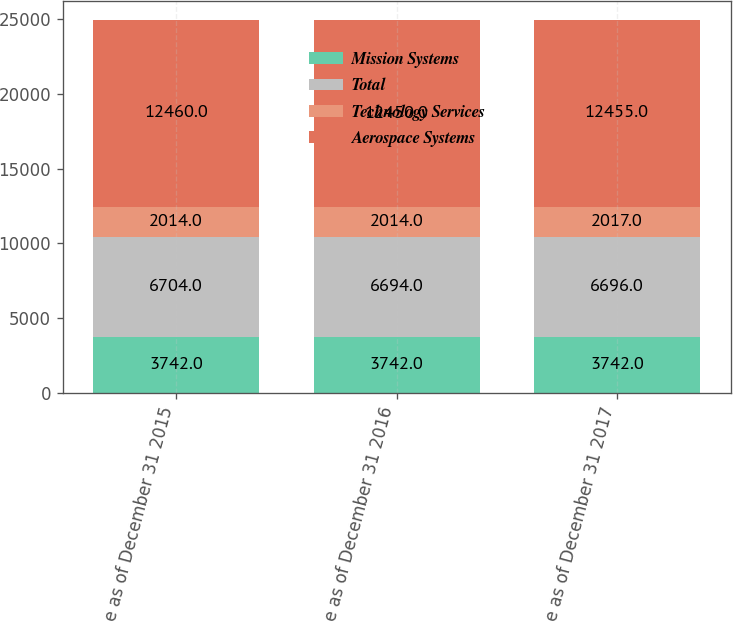Convert chart. <chart><loc_0><loc_0><loc_500><loc_500><stacked_bar_chart><ecel><fcel>Balance as of December 31 2015<fcel>Balance as of December 31 2016<fcel>Balance as of December 31 2017<nl><fcel>Mission Systems<fcel>3742<fcel>3742<fcel>3742<nl><fcel>Total<fcel>6704<fcel>6694<fcel>6696<nl><fcel>Technology Services<fcel>2014<fcel>2014<fcel>2017<nl><fcel>Aerospace Systems<fcel>12460<fcel>12450<fcel>12455<nl></chart> 